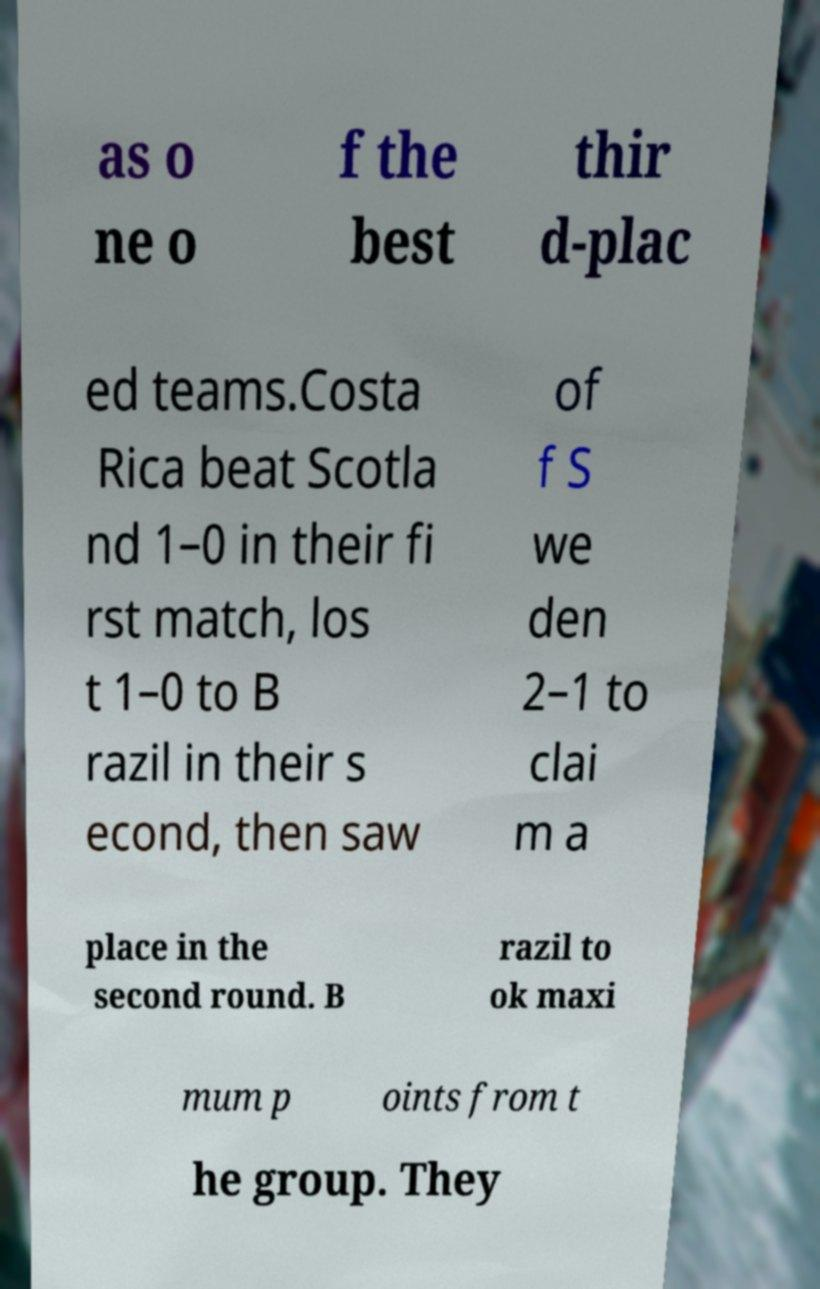Please read and relay the text visible in this image. What does it say? as o ne o f the best thir d-plac ed teams.Costa Rica beat Scotla nd 1–0 in their fi rst match, los t 1–0 to B razil in their s econd, then saw of f S we den 2–1 to clai m a place in the second round. B razil to ok maxi mum p oints from t he group. They 